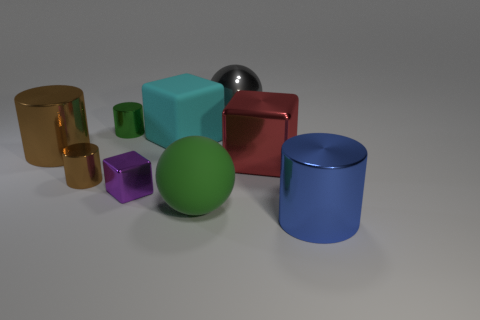Subtract all cyan spheres. How many brown cylinders are left? 2 Add 1 big brown metallic objects. How many objects exist? 10 Subtract all large cubes. How many cubes are left? 1 Subtract all green cylinders. How many cylinders are left? 3 Subtract 1 cubes. How many cubes are left? 2 Subtract all cylinders. How many objects are left? 5 Subtract all green blocks. Subtract all blue cylinders. How many blocks are left? 3 Subtract all green shiny objects. Subtract all red things. How many objects are left? 7 Add 8 cyan things. How many cyan things are left? 9 Add 5 large red matte balls. How many large red matte balls exist? 5 